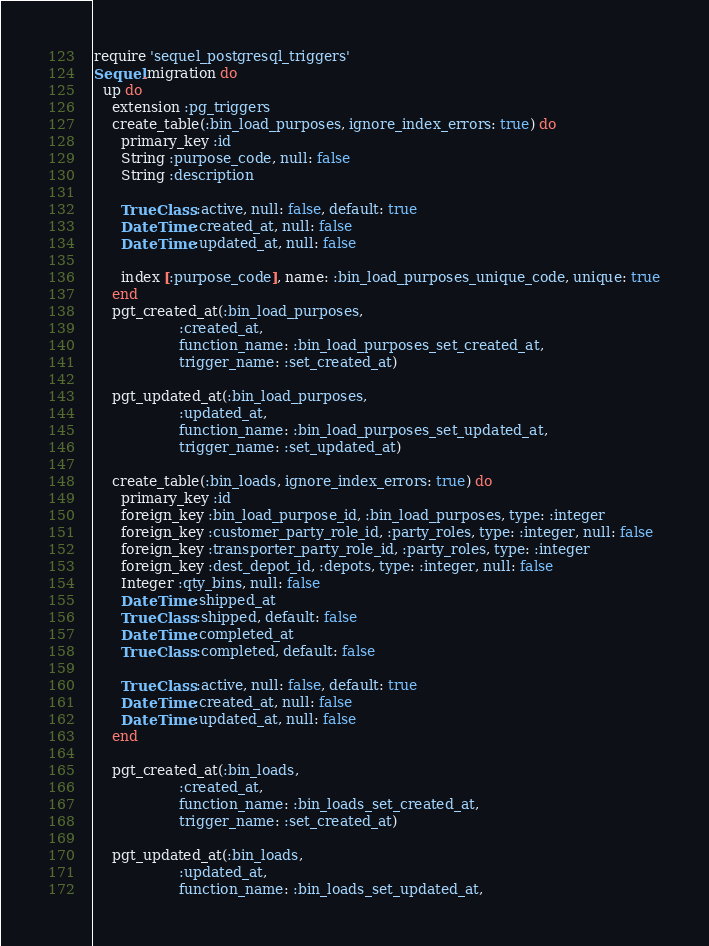<code> <loc_0><loc_0><loc_500><loc_500><_Ruby_>require 'sequel_postgresql_triggers'
Sequel.migration do
  up do
    extension :pg_triggers
    create_table(:bin_load_purposes, ignore_index_errors: true) do
      primary_key :id
      String :purpose_code, null: false
      String :description

      TrueClass :active, null: false, default: true
      DateTime :created_at, null: false
      DateTime :updated_at, null: false

      index [:purpose_code], name: :bin_load_purposes_unique_code, unique: true
    end
    pgt_created_at(:bin_load_purposes,
                   :created_at,
                   function_name: :bin_load_purposes_set_created_at,
                   trigger_name: :set_created_at)

    pgt_updated_at(:bin_load_purposes,
                   :updated_at,
                   function_name: :bin_load_purposes_set_updated_at,
                   trigger_name: :set_updated_at)

    create_table(:bin_loads, ignore_index_errors: true) do
      primary_key :id
      foreign_key :bin_load_purpose_id, :bin_load_purposes, type: :integer
      foreign_key :customer_party_role_id, :party_roles, type: :integer, null: false
      foreign_key :transporter_party_role_id, :party_roles, type: :integer
      foreign_key :dest_depot_id, :depots, type: :integer, null: false
      Integer :qty_bins, null: false
      DateTime :shipped_at
      TrueClass :shipped, default: false
      DateTime :completed_at
      TrueClass :completed, default: false

      TrueClass :active, null: false, default: true
      DateTime :created_at, null: false
      DateTime :updated_at, null: false
    end

    pgt_created_at(:bin_loads,
                   :created_at,
                   function_name: :bin_loads_set_created_at,
                   trigger_name: :set_created_at)

    pgt_updated_at(:bin_loads,
                   :updated_at,
                   function_name: :bin_loads_set_updated_at,</code> 